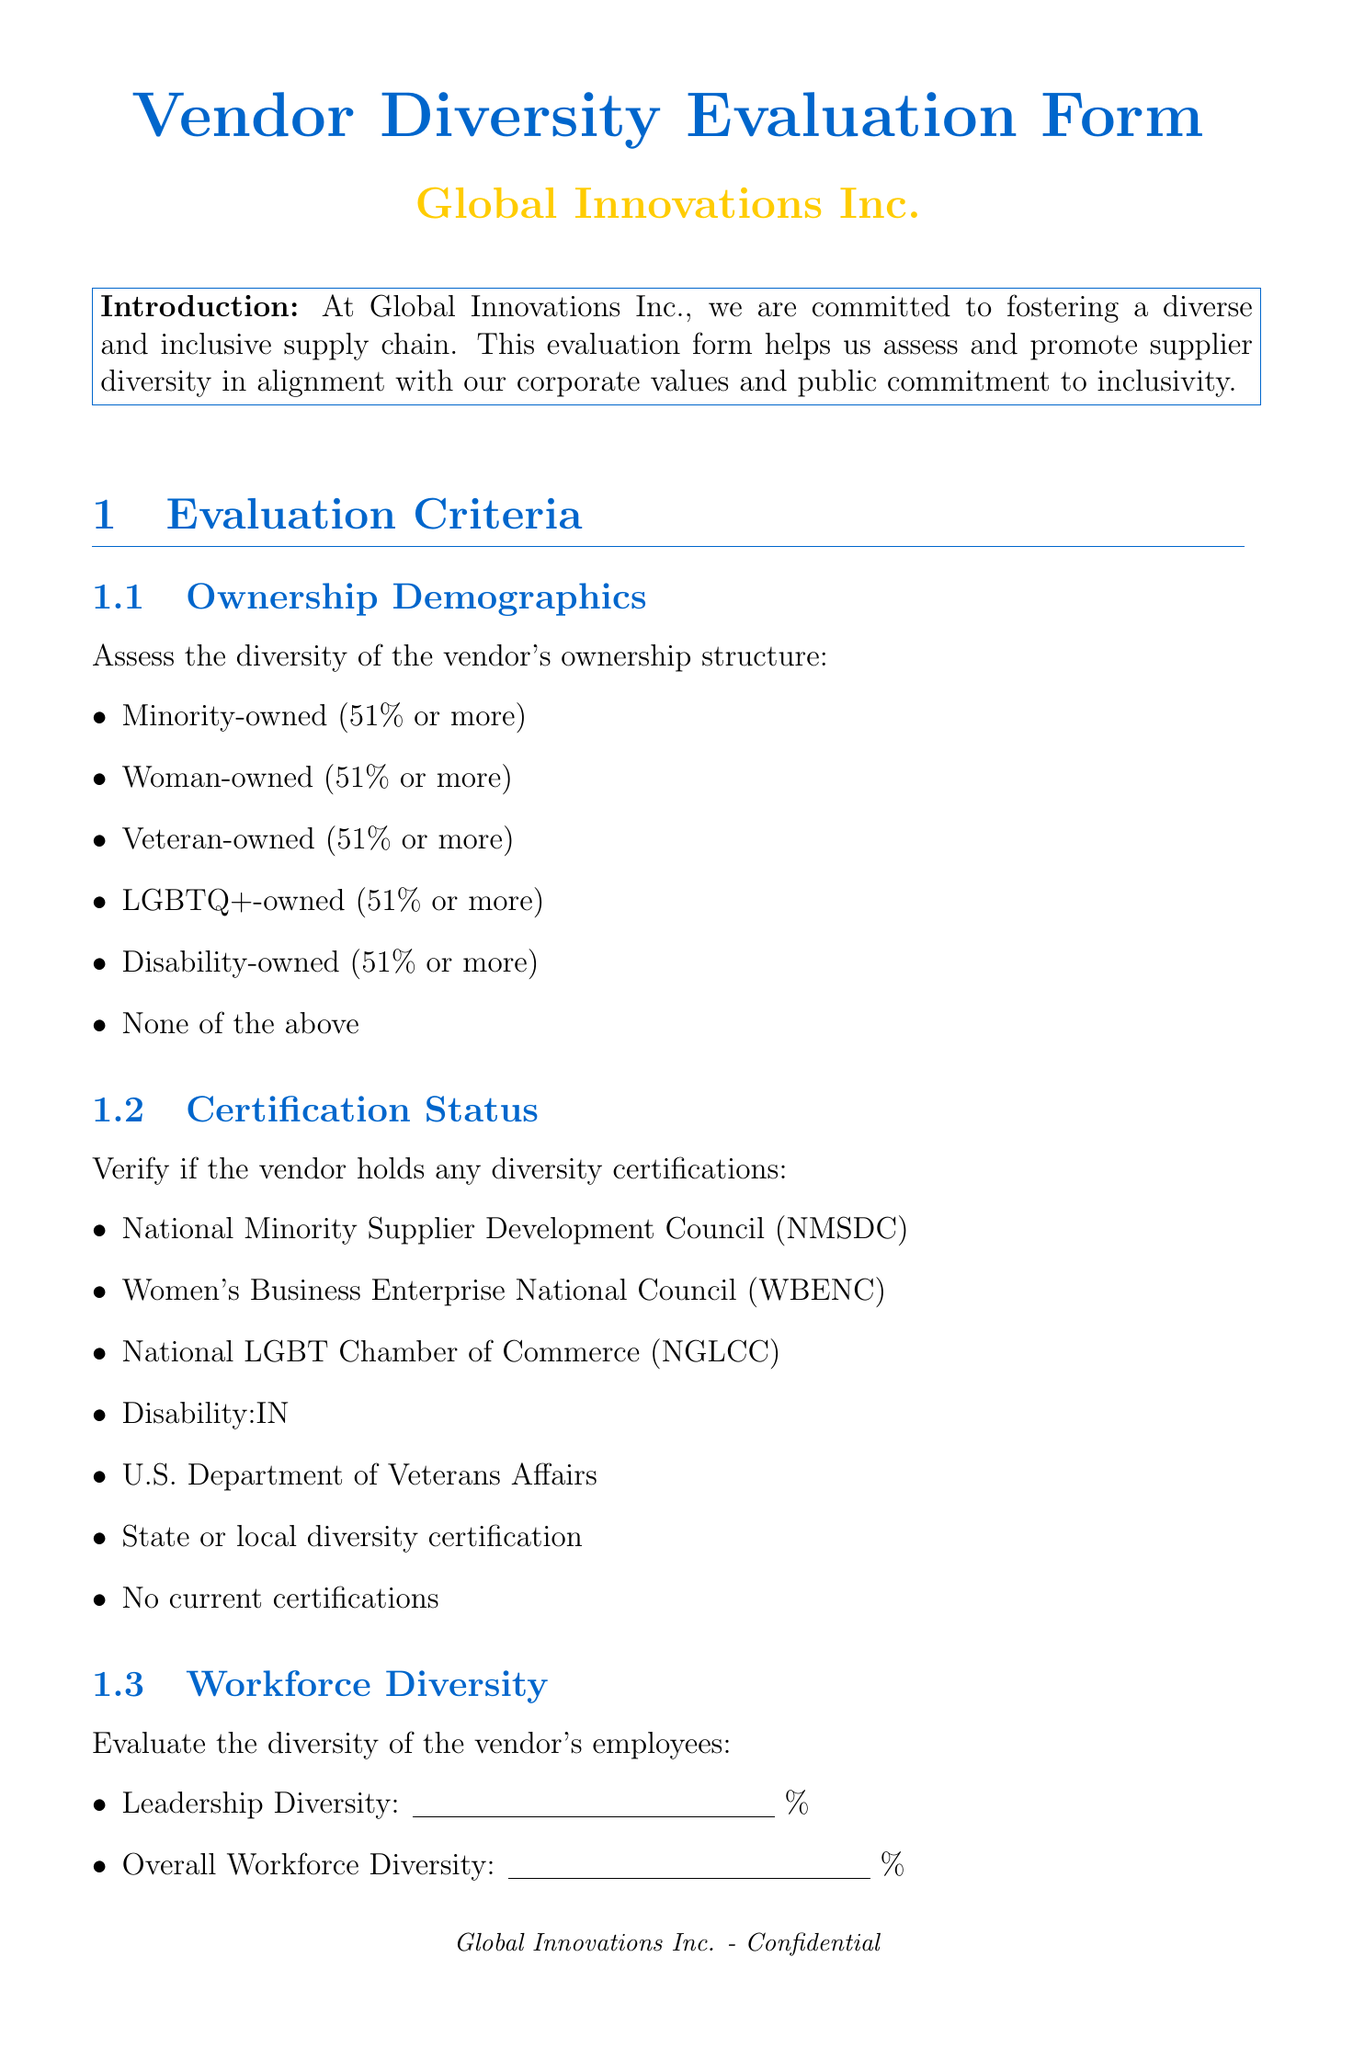What is the title of the form? The title of the form is presented prominently at the beginning of the document.
Answer: Vendor Diversity Evaluation Form Who is the company behind the form? The company name is specified in the introduction and header.
Answer: Global Innovations Inc What is the primary commitment of Global Innovations Inc.? This is noted in the introduction section which describes the company's focus.
Answer: Fostering a diverse and inclusive supply chain How many options are provided under Ownership Demographics? The list of options for the criteria is found in the document under the respective section.
Answer: Six What is the highest score range in the scoring system? The scoring system details the ranges for the scoring criteria.
Answer: 25-30 What type of training is mentioned under Inclusion Practices? The document lists various internal practices and one is explicitly about training.
Answer: Diversity and inclusion training for employees What should evaluators provide in the Additional Comments section? The guidelines for this section are provided in the format of a prompt.
Answer: Additional information or context regarding the vendor's diversity and inclusion efforts What date-related information is requested from the evaluator? The evaluator info section specifies what should be noted by the evaluator.
Answer: Date of Evaluation 